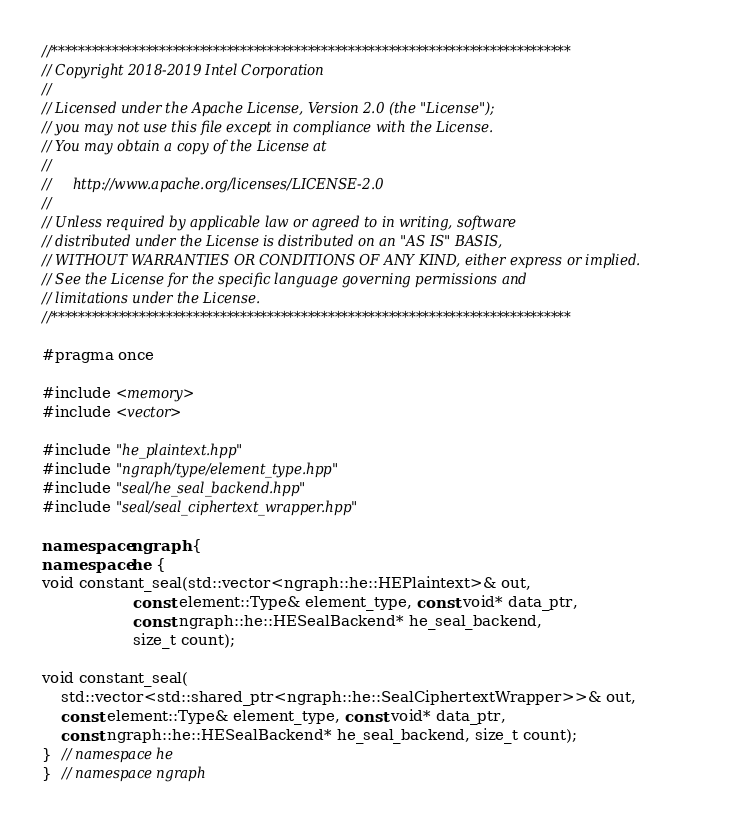Convert code to text. <code><loc_0><loc_0><loc_500><loc_500><_C++_>//*****************************************************************************
// Copyright 2018-2019 Intel Corporation
//
// Licensed under the Apache License, Version 2.0 (the "License");
// you may not use this file except in compliance with the License.
// You may obtain a copy of the License at
//
//     http://www.apache.org/licenses/LICENSE-2.0
//
// Unless required by applicable law or agreed to in writing, software
// distributed under the License is distributed on an "AS IS" BASIS,
// WITHOUT WARRANTIES OR CONDITIONS OF ANY KIND, either express or implied.
// See the License for the specific language governing permissions and
// limitations under the License.
//*****************************************************************************

#pragma once

#include <memory>
#include <vector>

#include "he_plaintext.hpp"
#include "ngraph/type/element_type.hpp"
#include "seal/he_seal_backend.hpp"
#include "seal/seal_ciphertext_wrapper.hpp"

namespace ngraph {
namespace he {
void constant_seal(std::vector<ngraph::he::HEPlaintext>& out,
                   const element::Type& element_type, const void* data_ptr,
                   const ngraph::he::HESealBackend* he_seal_backend,
                   size_t count);

void constant_seal(
    std::vector<std::shared_ptr<ngraph::he::SealCiphertextWrapper>>& out,
    const element::Type& element_type, const void* data_ptr,
    const ngraph::he::HESealBackend* he_seal_backend, size_t count);
}  // namespace he
}  // namespace ngraph
</code> 